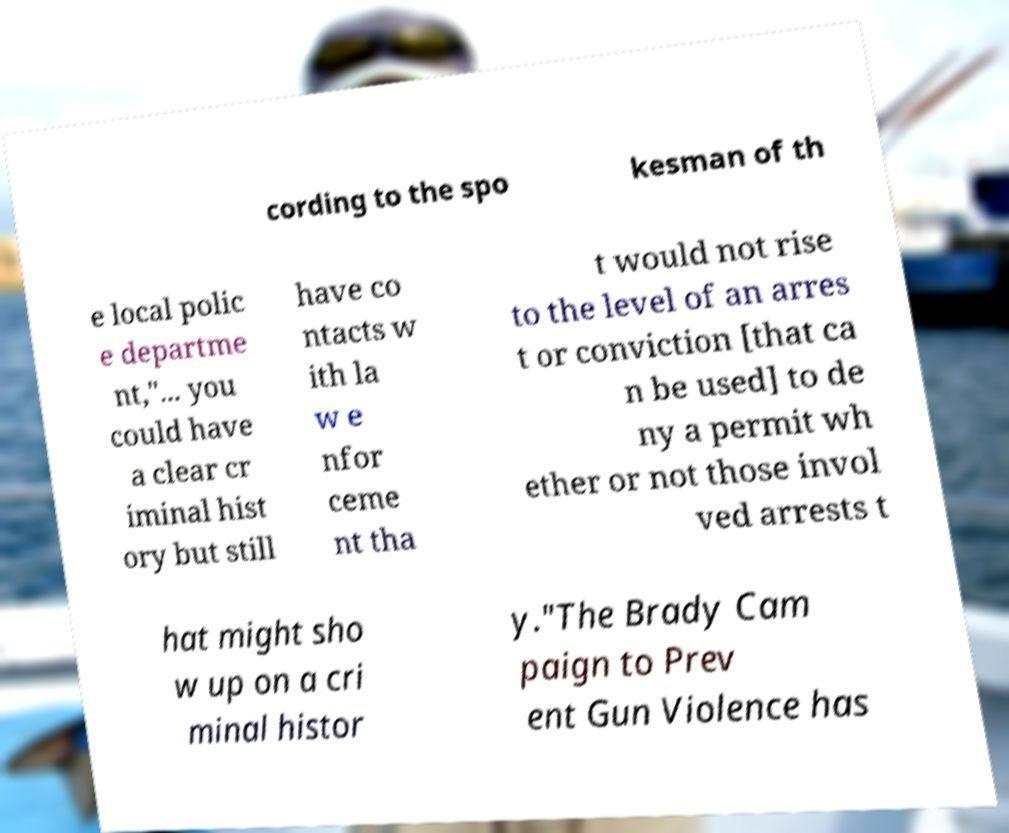Please identify and transcribe the text found in this image. cording to the spo kesman of th e local polic e departme nt,"... you could have a clear cr iminal hist ory but still have co ntacts w ith la w e nfor ceme nt tha t would not rise to the level of an arres t or conviction [that ca n be used] to de ny a permit wh ether or not those invol ved arrests t hat might sho w up on a cri minal histor y."The Brady Cam paign to Prev ent Gun Violence has 